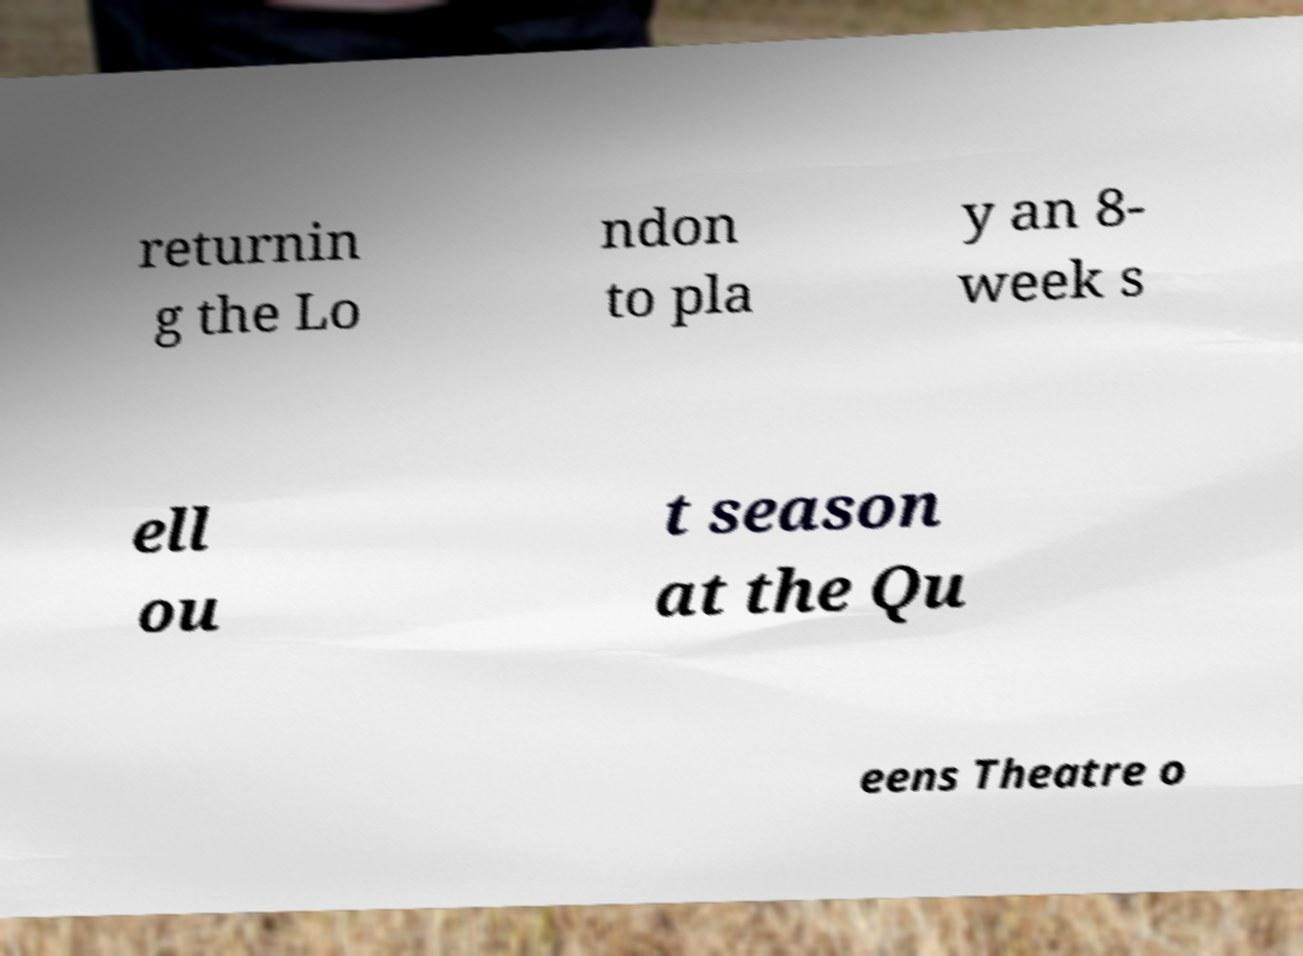For documentation purposes, I need the text within this image transcribed. Could you provide that? returnin g the Lo ndon to pla y an 8- week s ell ou t season at the Qu eens Theatre o 